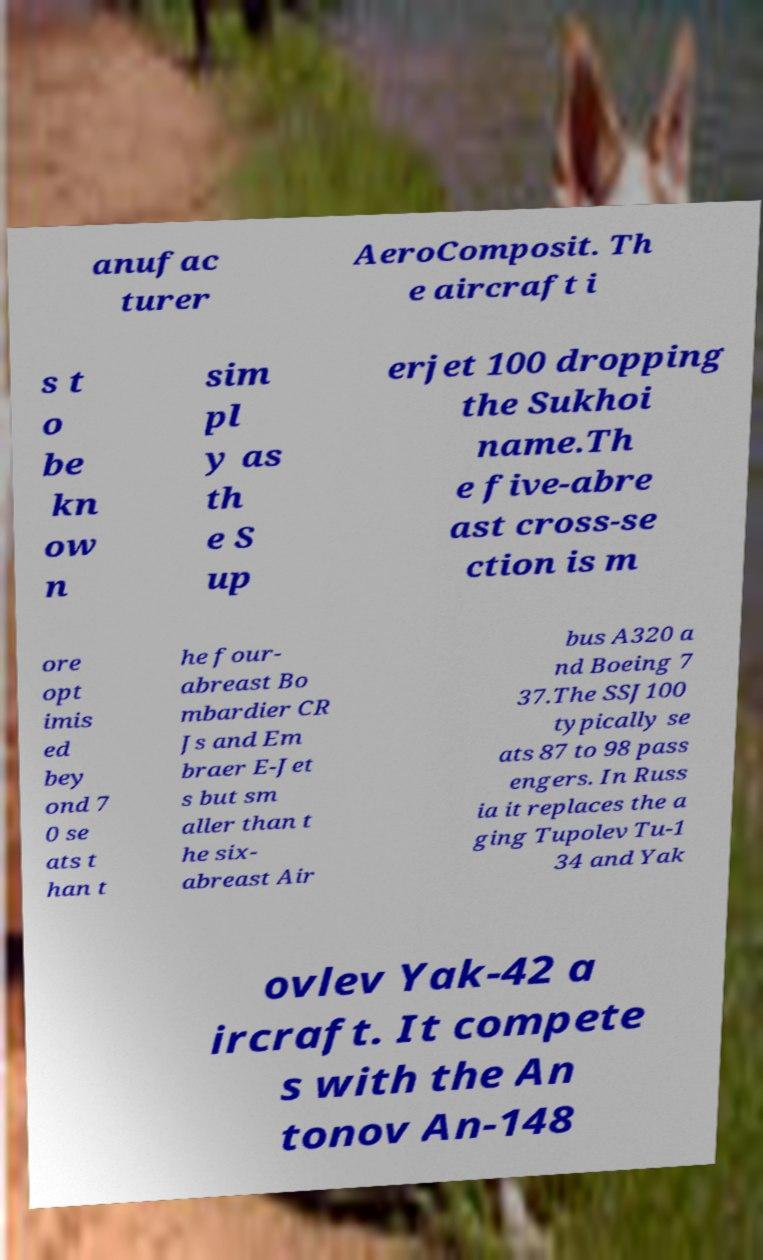Please read and relay the text visible in this image. What does it say? anufac turer AeroComposit. Th e aircraft i s t o be kn ow n sim pl y as th e S up erjet 100 dropping the Sukhoi name.Th e five-abre ast cross-se ction is m ore opt imis ed bey ond 7 0 se ats t han t he four- abreast Bo mbardier CR Js and Em braer E-Jet s but sm aller than t he six- abreast Air bus A320 a nd Boeing 7 37.The SSJ100 typically se ats 87 to 98 pass engers. In Russ ia it replaces the a ging Tupolev Tu-1 34 and Yak ovlev Yak-42 a ircraft. It compete s with the An tonov An-148 